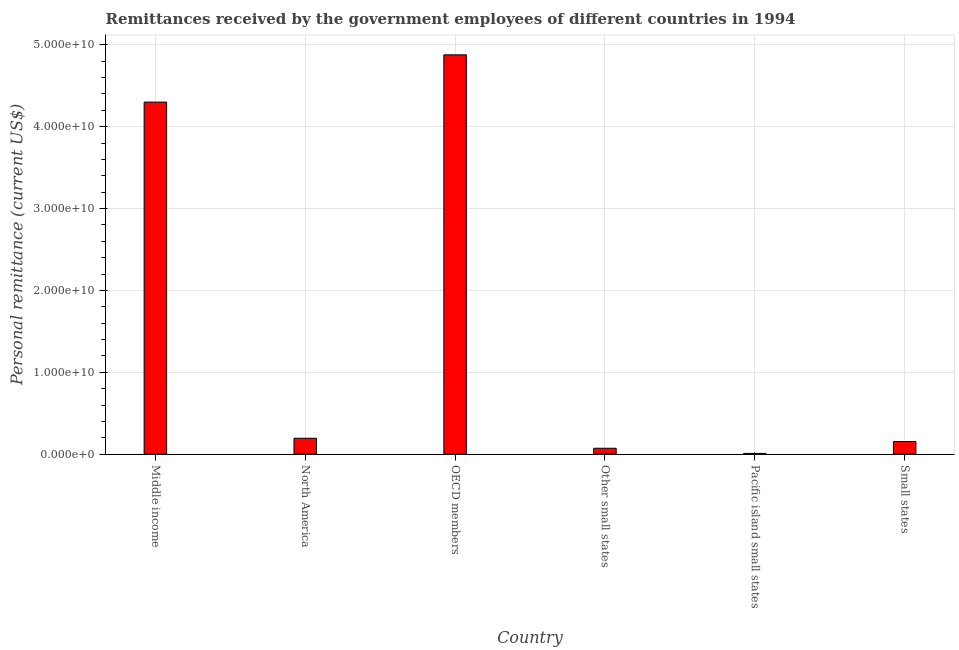Does the graph contain grids?
Ensure brevity in your answer.  Yes. What is the title of the graph?
Provide a succinct answer. Remittances received by the government employees of different countries in 1994. What is the label or title of the X-axis?
Ensure brevity in your answer.  Country. What is the label or title of the Y-axis?
Ensure brevity in your answer.  Personal remittance (current US$). What is the personal remittances in North America?
Offer a very short reply. 1.94e+09. Across all countries, what is the maximum personal remittances?
Keep it short and to the point. 4.88e+1. Across all countries, what is the minimum personal remittances?
Provide a short and direct response. 9.17e+07. In which country was the personal remittances minimum?
Your answer should be compact. Pacific island small states. What is the sum of the personal remittances?
Offer a terse response. 9.61e+1. What is the difference between the personal remittances in Other small states and Small states?
Give a very brief answer. -8.20e+08. What is the average personal remittances per country?
Keep it short and to the point. 1.60e+1. What is the median personal remittances?
Provide a short and direct response. 1.74e+09. In how many countries, is the personal remittances greater than 24000000000 US$?
Ensure brevity in your answer.  2. What is the ratio of the personal remittances in OECD members to that in Other small states?
Your response must be concise. 67.55. What is the difference between the highest and the second highest personal remittances?
Your answer should be very brief. 5.78e+09. Is the sum of the personal remittances in Other small states and Small states greater than the maximum personal remittances across all countries?
Offer a very short reply. No. What is the difference between the highest and the lowest personal remittances?
Your answer should be very brief. 4.87e+1. How many bars are there?
Ensure brevity in your answer.  6. What is the difference between two consecutive major ticks on the Y-axis?
Provide a short and direct response. 1.00e+1. Are the values on the major ticks of Y-axis written in scientific E-notation?
Give a very brief answer. Yes. What is the Personal remittance (current US$) of Middle income?
Give a very brief answer. 4.30e+1. What is the Personal remittance (current US$) of North America?
Give a very brief answer. 1.94e+09. What is the Personal remittance (current US$) in OECD members?
Make the answer very short. 4.88e+1. What is the Personal remittance (current US$) of Other small states?
Provide a succinct answer. 7.22e+08. What is the Personal remittance (current US$) of Pacific island small states?
Offer a very short reply. 9.17e+07. What is the Personal remittance (current US$) in Small states?
Your answer should be very brief. 1.54e+09. What is the difference between the Personal remittance (current US$) in Middle income and North America?
Provide a short and direct response. 4.11e+1. What is the difference between the Personal remittance (current US$) in Middle income and OECD members?
Ensure brevity in your answer.  -5.78e+09. What is the difference between the Personal remittance (current US$) in Middle income and Other small states?
Provide a succinct answer. 4.23e+1. What is the difference between the Personal remittance (current US$) in Middle income and Pacific island small states?
Provide a short and direct response. 4.29e+1. What is the difference between the Personal remittance (current US$) in Middle income and Small states?
Give a very brief answer. 4.15e+1. What is the difference between the Personal remittance (current US$) in North America and OECD members?
Ensure brevity in your answer.  -4.68e+1. What is the difference between the Personal remittance (current US$) in North America and Other small states?
Keep it short and to the point. 1.22e+09. What is the difference between the Personal remittance (current US$) in North America and Pacific island small states?
Make the answer very short. 1.85e+09. What is the difference between the Personal remittance (current US$) in North America and Small states?
Ensure brevity in your answer.  4.01e+08. What is the difference between the Personal remittance (current US$) in OECD members and Other small states?
Ensure brevity in your answer.  4.81e+1. What is the difference between the Personal remittance (current US$) in OECD members and Pacific island small states?
Ensure brevity in your answer.  4.87e+1. What is the difference between the Personal remittance (current US$) in OECD members and Small states?
Provide a succinct answer. 4.72e+1. What is the difference between the Personal remittance (current US$) in Other small states and Pacific island small states?
Provide a succinct answer. 6.30e+08. What is the difference between the Personal remittance (current US$) in Other small states and Small states?
Your answer should be very brief. -8.20e+08. What is the difference between the Personal remittance (current US$) in Pacific island small states and Small states?
Make the answer very short. -1.45e+09. What is the ratio of the Personal remittance (current US$) in Middle income to that in North America?
Your answer should be very brief. 22.13. What is the ratio of the Personal remittance (current US$) in Middle income to that in OECD members?
Your response must be concise. 0.88. What is the ratio of the Personal remittance (current US$) in Middle income to that in Other small states?
Offer a very short reply. 59.55. What is the ratio of the Personal remittance (current US$) in Middle income to that in Pacific island small states?
Offer a terse response. 469.19. What is the ratio of the Personal remittance (current US$) in Middle income to that in Small states?
Your answer should be compact. 27.89. What is the ratio of the Personal remittance (current US$) in North America to that in Other small states?
Offer a very short reply. 2.69. What is the ratio of the Personal remittance (current US$) in North America to that in Pacific island small states?
Provide a succinct answer. 21.2. What is the ratio of the Personal remittance (current US$) in North America to that in Small states?
Offer a very short reply. 1.26. What is the ratio of the Personal remittance (current US$) in OECD members to that in Other small states?
Your answer should be compact. 67.55. What is the ratio of the Personal remittance (current US$) in OECD members to that in Pacific island small states?
Your response must be concise. 532.2. What is the ratio of the Personal remittance (current US$) in OECD members to that in Small states?
Your response must be concise. 31.63. What is the ratio of the Personal remittance (current US$) in Other small states to that in Pacific island small states?
Your answer should be compact. 7.88. What is the ratio of the Personal remittance (current US$) in Other small states to that in Small states?
Offer a terse response. 0.47. What is the ratio of the Personal remittance (current US$) in Pacific island small states to that in Small states?
Your response must be concise. 0.06. 